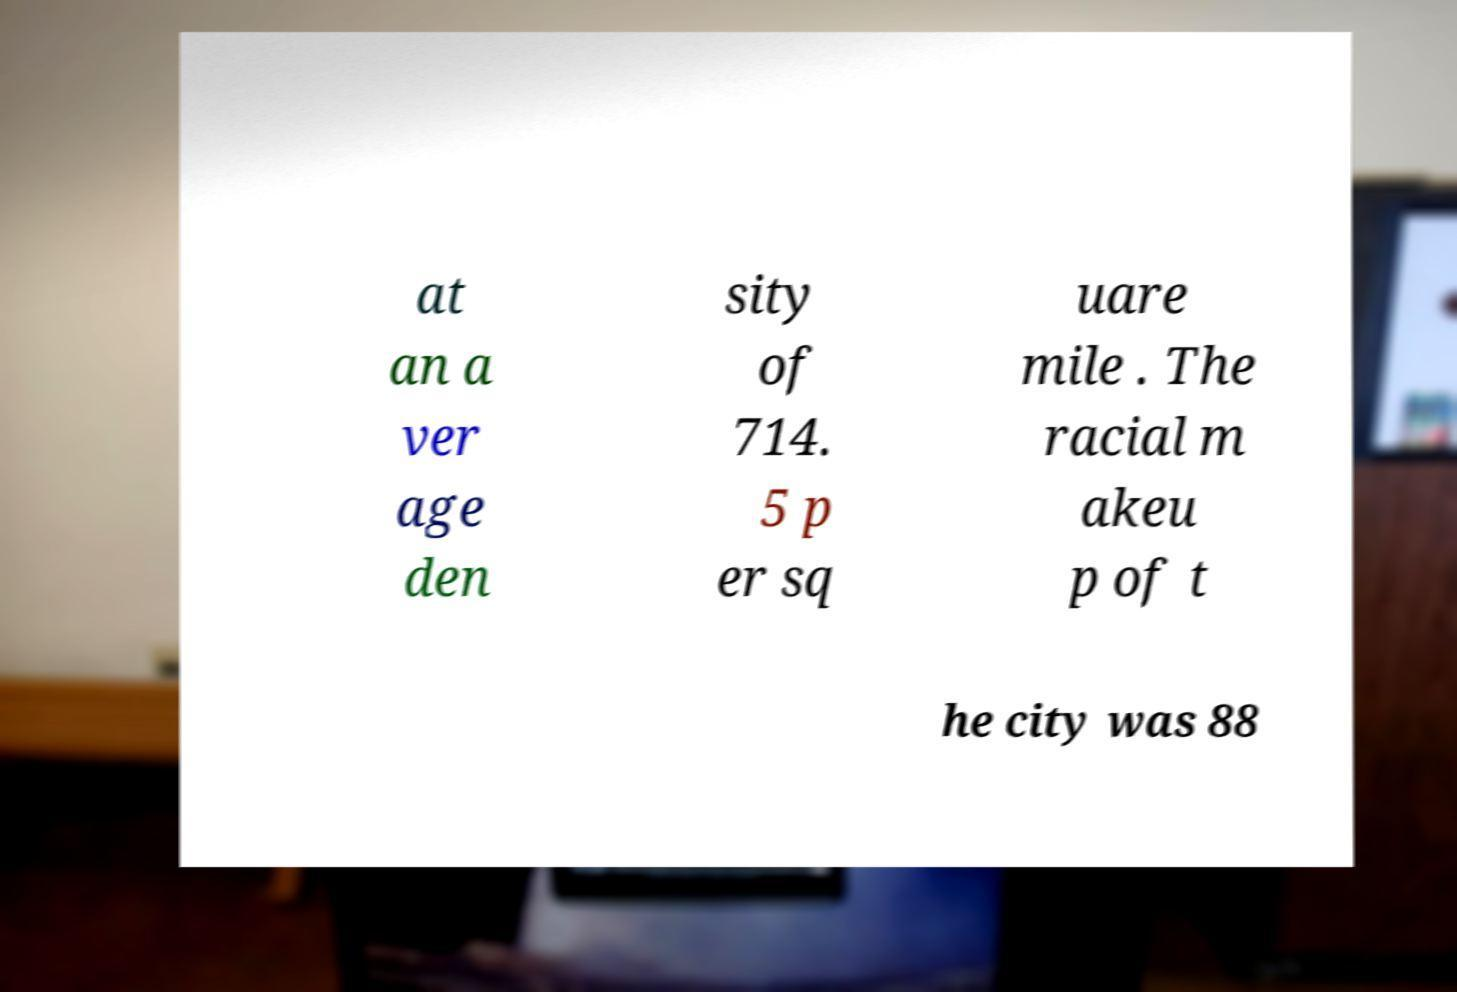Could you extract and type out the text from this image? at an a ver age den sity of 714. 5 p er sq uare mile . The racial m akeu p of t he city was 88 